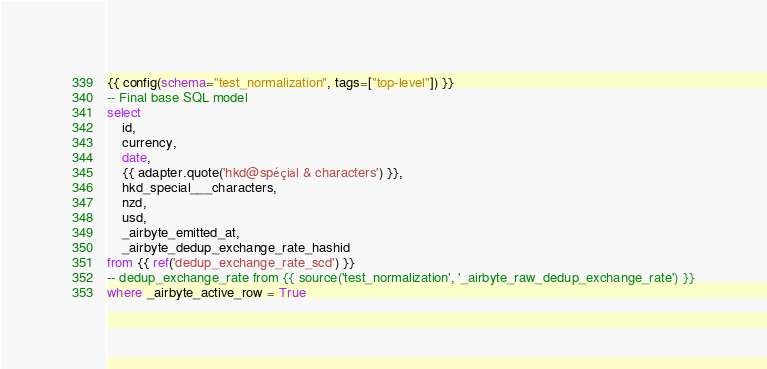<code> <loc_0><loc_0><loc_500><loc_500><_SQL_>{{ config(schema="test_normalization", tags=["top-level"]) }}
-- Final base SQL model
select
    id,
    currency,
    date,
    {{ adapter.quote('hkd@spéçiäl & characters') }},
    hkd_special___characters,
    nzd,
    usd,
    _airbyte_emitted_at,
    _airbyte_dedup_exchange_rate_hashid
from {{ ref('dedup_exchange_rate_scd') }}
-- dedup_exchange_rate from {{ source('test_normalization', '_airbyte_raw_dedup_exchange_rate') }}
where _airbyte_active_row = True

</code> 